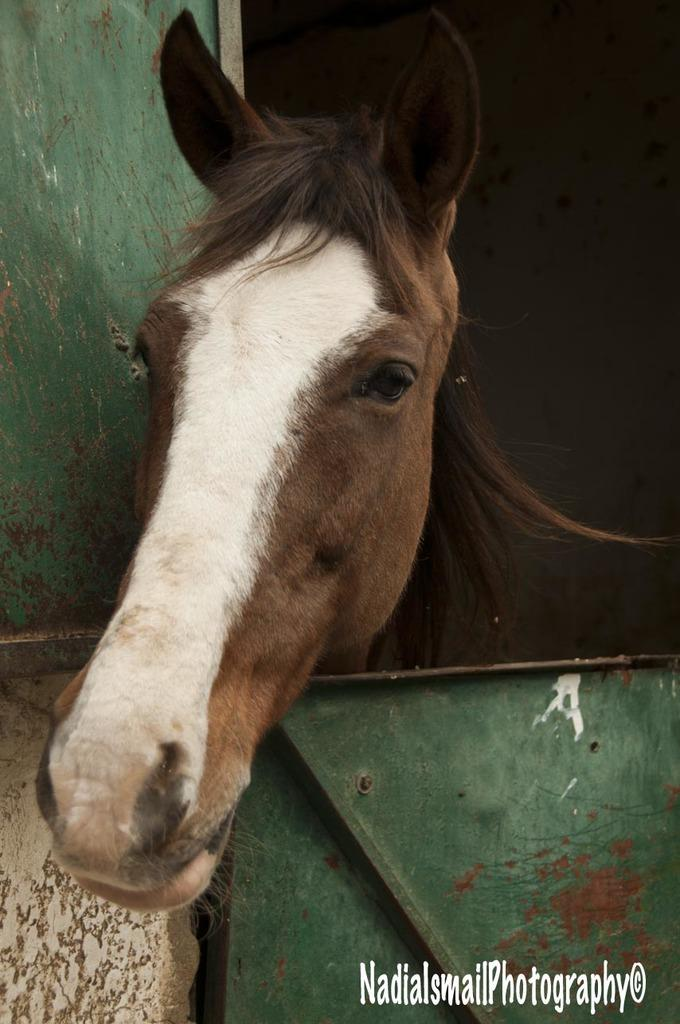What animal is present in the image? There is a horse in the image. Can you describe the color of the horse? The horse has brown and white color. Where is the horse located in relation to other objects in the image? The horse is standing in front of a door. Are there any fairies flying around the horse in the image? There is no mention of fairies in the image, so we cannot say if they are present or not. 